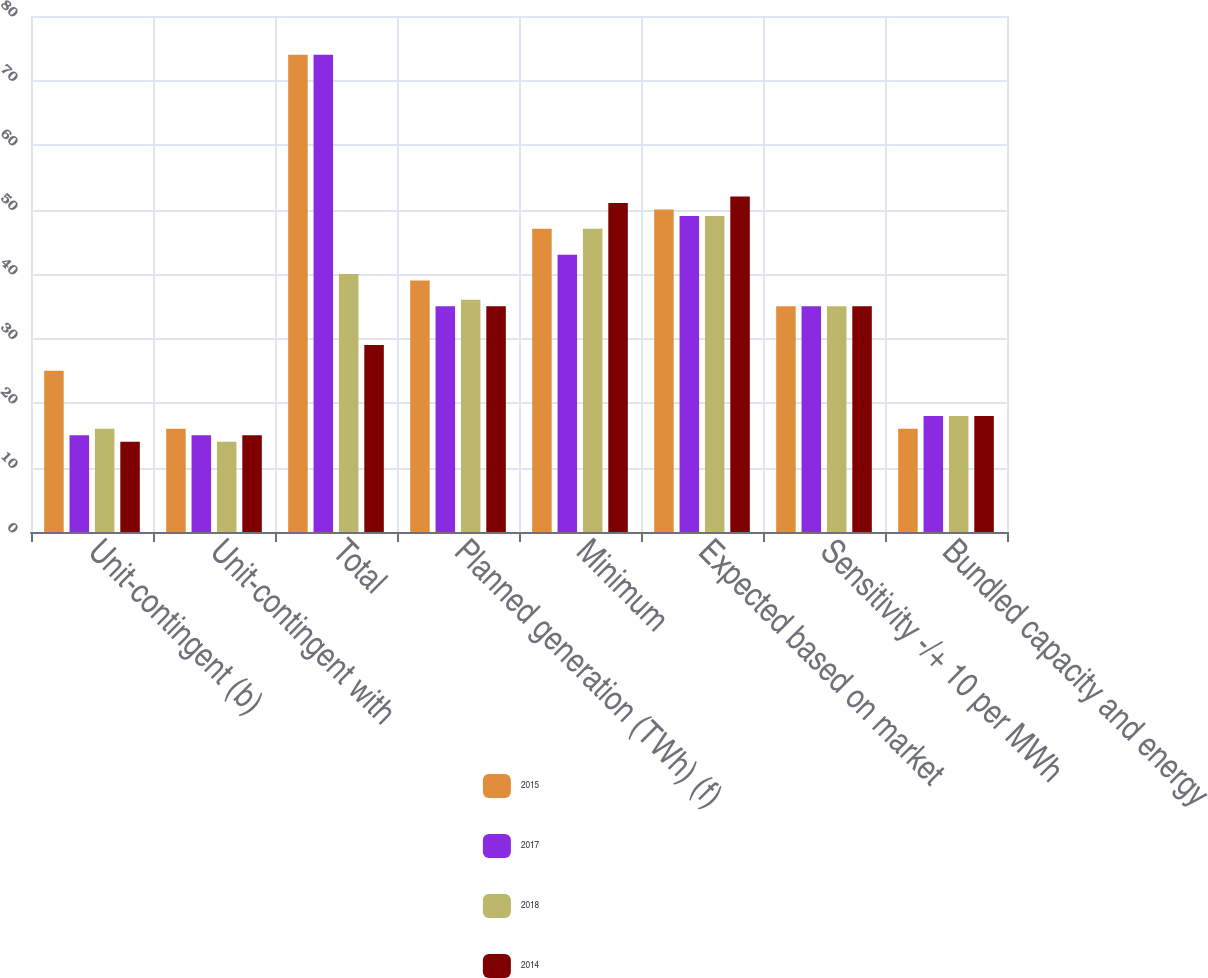Convert chart. <chart><loc_0><loc_0><loc_500><loc_500><stacked_bar_chart><ecel><fcel>Unit-contingent (b)<fcel>Unit-contingent with<fcel>Total<fcel>Planned generation (TWh) (f)<fcel>Minimum<fcel>Expected based on market<fcel>Sensitivity -/+ 10 per MWh<fcel>Bundled capacity and energy<nl><fcel>2015<fcel>25<fcel>16<fcel>74<fcel>39<fcel>47<fcel>50<fcel>35<fcel>16<nl><fcel>2017<fcel>15<fcel>15<fcel>74<fcel>35<fcel>43<fcel>49<fcel>35<fcel>18<nl><fcel>2018<fcel>16<fcel>14<fcel>40<fcel>36<fcel>47<fcel>49<fcel>35<fcel>18<nl><fcel>2014<fcel>14<fcel>15<fcel>29<fcel>35<fcel>51<fcel>52<fcel>35<fcel>18<nl></chart> 